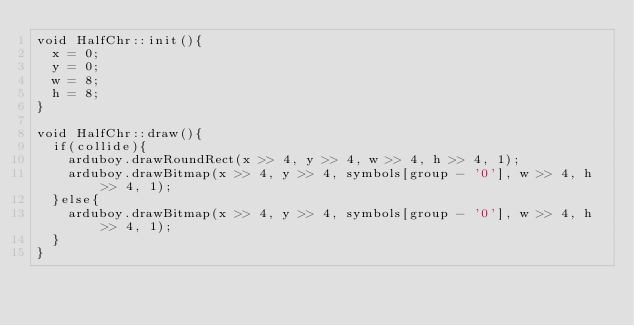<code> <loc_0><loc_0><loc_500><loc_500><_C++_>void HalfChr::init(){
  x = 0;
  y = 0;
  w = 8;
  h = 8;
}

void HalfChr::draw(){
  if(collide){
    arduboy.drawRoundRect(x >> 4, y >> 4, w >> 4, h >> 4, 1);
    arduboy.drawBitmap(x >> 4, y >> 4, symbols[group - '0'], w >> 4, h >> 4, 1);
  }else{
    arduboy.drawBitmap(x >> 4, y >> 4, symbols[group - '0'], w >> 4, h >> 4, 1);
  }
}

</code> 